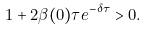Convert formula to latex. <formula><loc_0><loc_0><loc_500><loc_500>1 + 2 \beta ( 0 ) \tau e ^ { - \delta \tau } > 0 .</formula> 